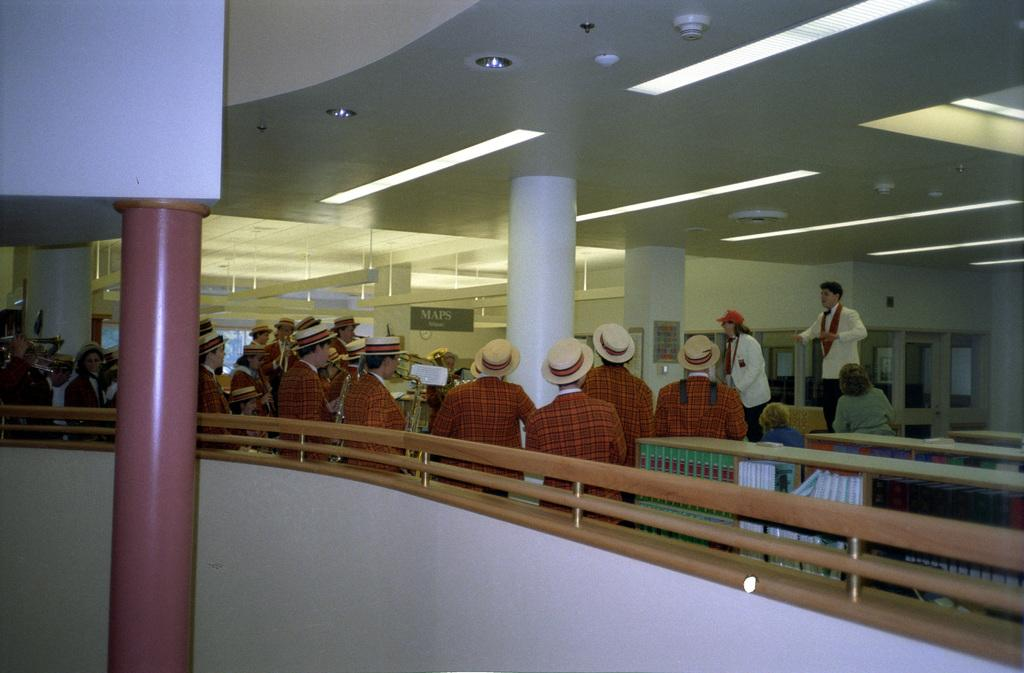Where was the image taken? The image was taken inside a building. What are the people in the center of the image doing? The people in the center of the image are wearing costumes. What type of furniture is present in the image? There are benches in the image. What architectural features can be seen in the image? There are pillars in the image. What is visible at the top of the image? There are lights visible at the top of the image. What type of wool is being used to create the flag in the image? There is no flag present in the image, so it is not possible to determine the type of wool being used. 